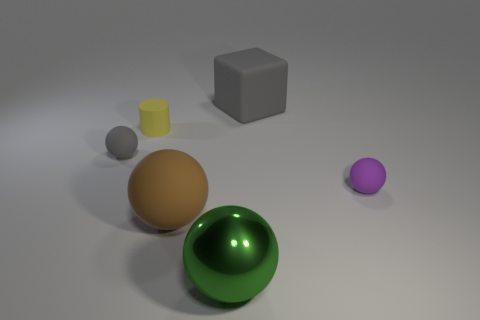Add 1 tiny red metal objects. How many objects exist? 7 Subtract all cyan spheres. Subtract all cyan cubes. How many spheres are left? 4 Subtract all blocks. How many objects are left? 5 Subtract all big yellow shiny things. Subtract all metal objects. How many objects are left? 5 Add 5 big brown matte balls. How many big brown matte balls are left? 6 Add 3 large metallic spheres. How many large metallic spheres exist? 4 Subtract 0 red balls. How many objects are left? 6 